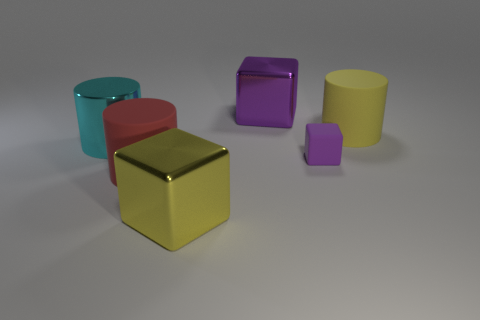Subtract all rubber cylinders. How many cylinders are left? 1 Subtract all yellow blocks. How many blocks are left? 2 Add 3 large green shiny cylinders. How many objects exist? 9 Subtract 2 cylinders. How many cylinders are left? 1 Subtract all cyan cylinders. How many purple blocks are left? 2 Add 5 yellow rubber objects. How many yellow rubber objects are left? 6 Add 6 big blue matte spheres. How many big blue matte spheres exist? 6 Subtract 0 gray cylinders. How many objects are left? 6 Subtract all green cylinders. Subtract all yellow balls. How many cylinders are left? 3 Subtract all small purple cylinders. Subtract all large shiny blocks. How many objects are left? 4 